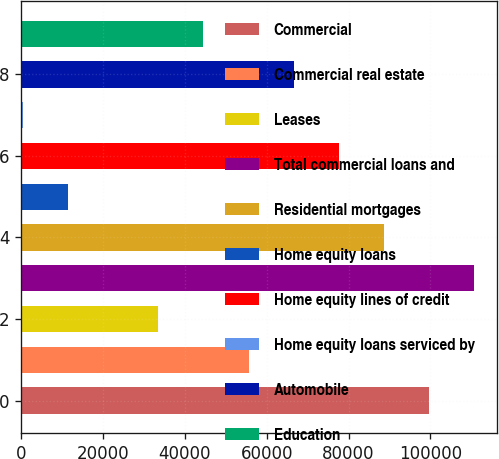Convert chart to OTSL. <chart><loc_0><loc_0><loc_500><loc_500><bar_chart><fcel>Commercial<fcel>Commercial real estate<fcel>Leases<fcel>Total commercial loans and<fcel>Residential mortgages<fcel>Home equity loans<fcel>Home equity lines of credit<fcel>Home equity loans serviced by<fcel>Automobile<fcel>Education<nl><fcel>99609.5<fcel>55579.5<fcel>33564.5<fcel>110617<fcel>88602<fcel>11549.5<fcel>77594.5<fcel>542<fcel>66587<fcel>44572<nl></chart> 